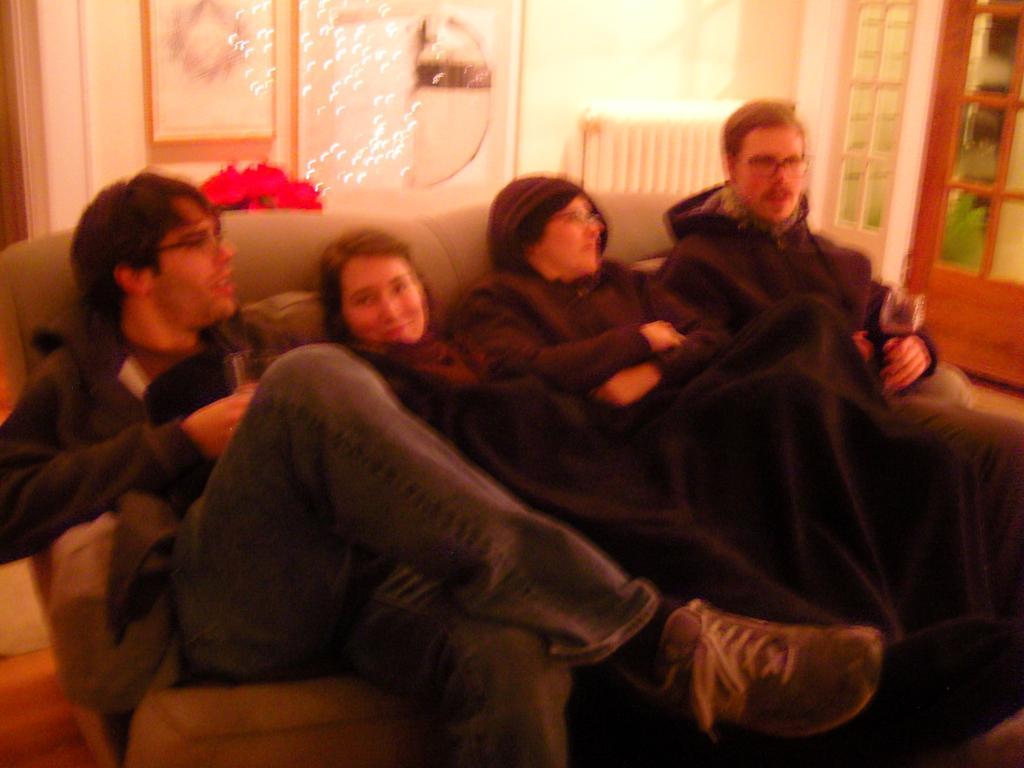Could you give a brief overview of what you see in this image? In this image we can see there are four people sitting on the couch, and on the right side there is the window. 